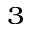Convert formula to latex. <formula><loc_0><loc_0><loc_500><loc_500>^ { 3 }</formula> 